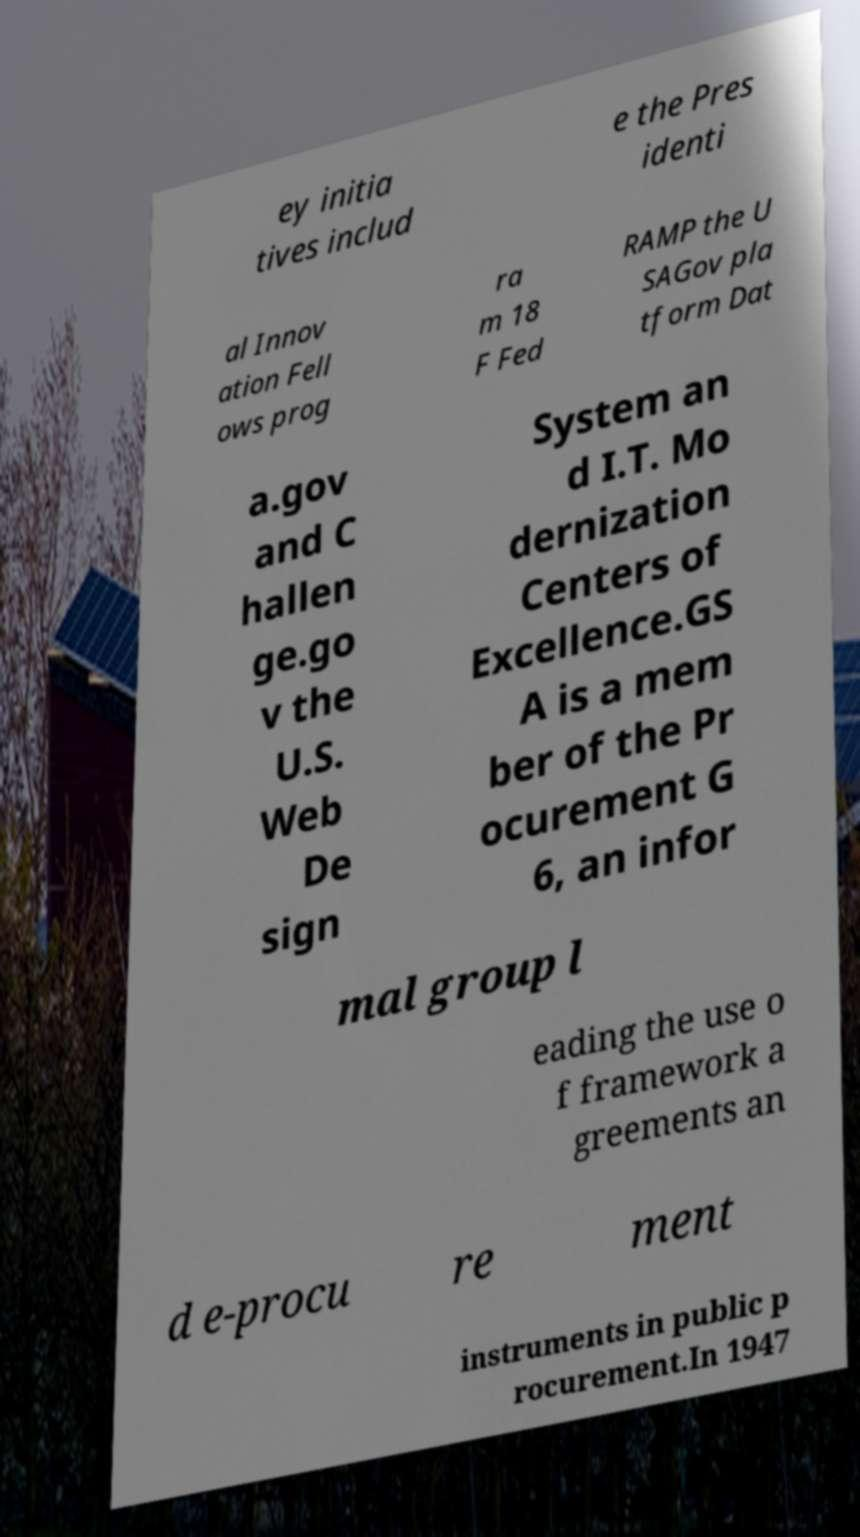What messages or text are displayed in this image? I need them in a readable, typed format. ey initia tives includ e the Pres identi al Innov ation Fell ows prog ra m 18 F Fed RAMP the U SAGov pla tform Dat a.gov and C hallen ge.go v the U.S. Web De sign System an d I.T. Mo dernization Centers of Excellence.GS A is a mem ber of the Pr ocurement G 6, an infor mal group l eading the use o f framework a greements an d e-procu re ment instruments in public p rocurement.In 1947 